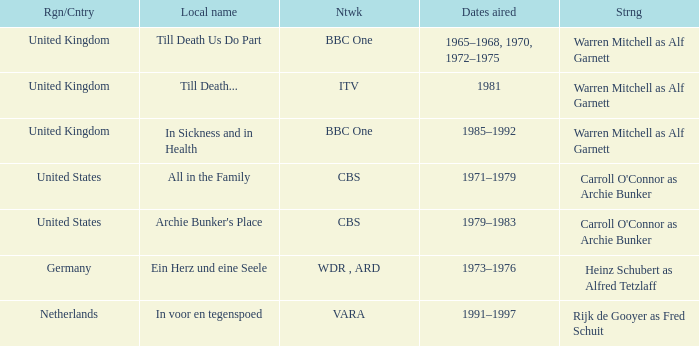Who was the star for the Vara network? Rijk de Gooyer as Fred Schuit. 